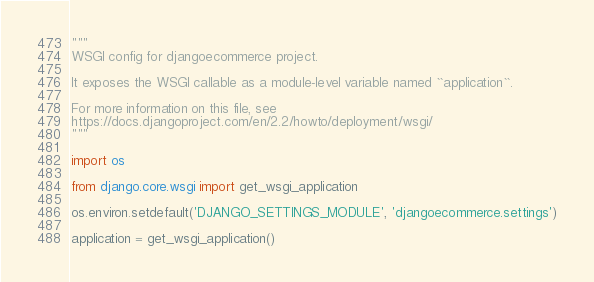<code> <loc_0><loc_0><loc_500><loc_500><_Python_>"""
WSGI config for djangoecommerce project.

It exposes the WSGI callable as a module-level variable named ``application``.

For more information on this file, see
https://docs.djangoproject.com/en/2.2/howto/deployment/wsgi/
"""

import os

from django.core.wsgi import get_wsgi_application

os.environ.setdefault('DJANGO_SETTINGS_MODULE', 'djangoecommerce.settings')

application = get_wsgi_application()
</code> 